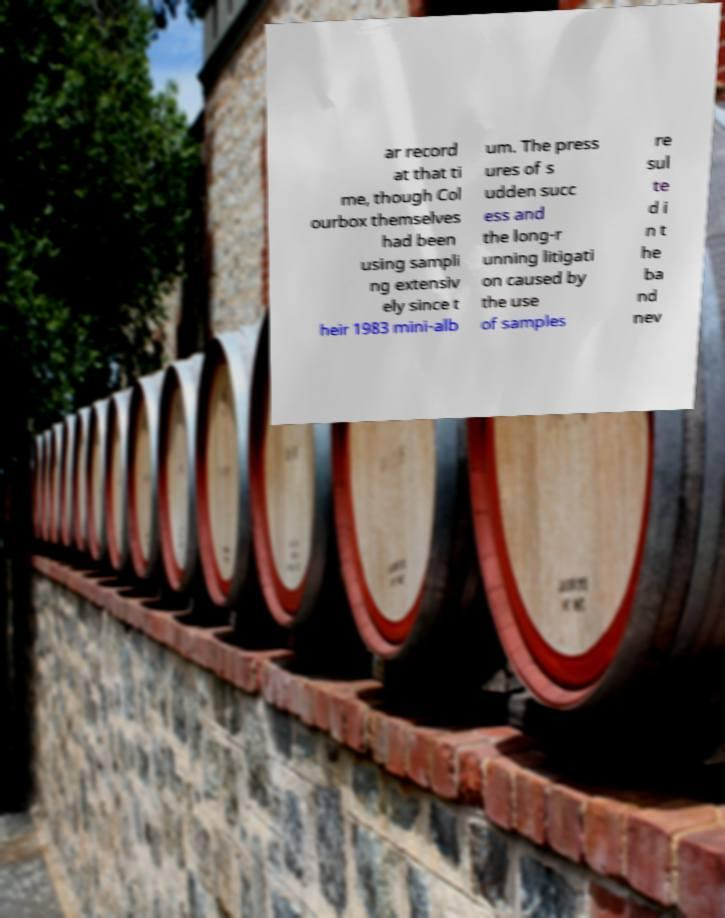Please read and relay the text visible in this image. What does it say? ar record at that ti me, though Col ourbox themselves had been using sampli ng extensiv ely since t heir 1983 mini-alb um. The press ures of s udden succ ess and the long-r unning litigati on caused by the use of samples re sul te d i n t he ba nd nev 